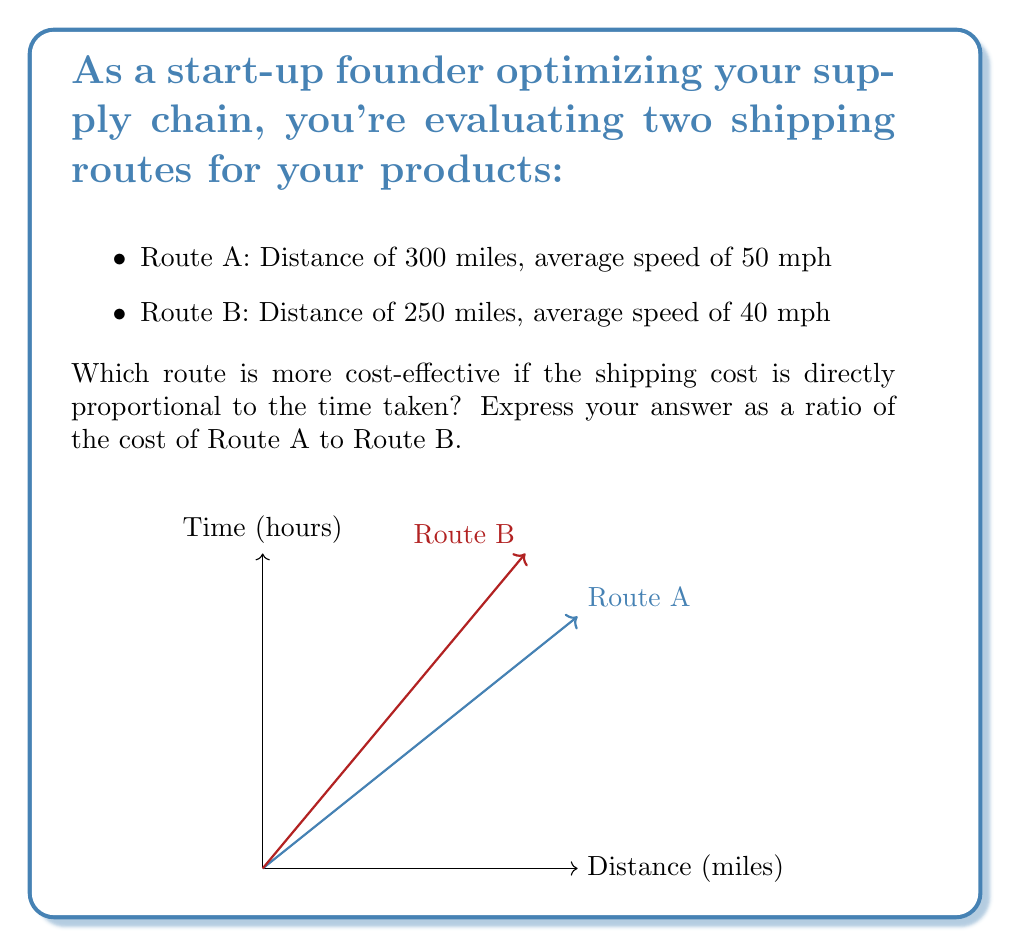Show me your answer to this math problem. Let's approach this step-by-step:

1) First, we need to calculate the time taken for each route.

   For Route A: 
   $$ \text{Time}_A = \frac{\text{Distance}_A}{\text{Speed}_A} = \frac{300 \text{ miles}}{50 \text{ mph}} = 6 \text{ hours} $$

   For Route B:
   $$ \text{Time}_B = \frac{\text{Distance}_B}{\text{Speed}_B} = \frac{250 \text{ miles}}{40 \text{ mph}} = 6.25 \text{ hours} $$

2) Since the shipping cost is directly proportional to the time taken, we can express the cost ratio as the ratio of the times:

   $$ \frac{\text{Cost}_A}{\text{Cost}_B} = \frac{\text{Time}_A}{\text{Time}_B} = \frac{6}{6.25} $$

3) To simplify this fraction:
   $$ \frac{6}{6.25} = \frac{6}{25/4} = \frac{6 \cdot 4}{25} = \frac{24}{25} $$

Therefore, the cost ratio of Route A to Route B is 24:25.
Answer: 24:25 